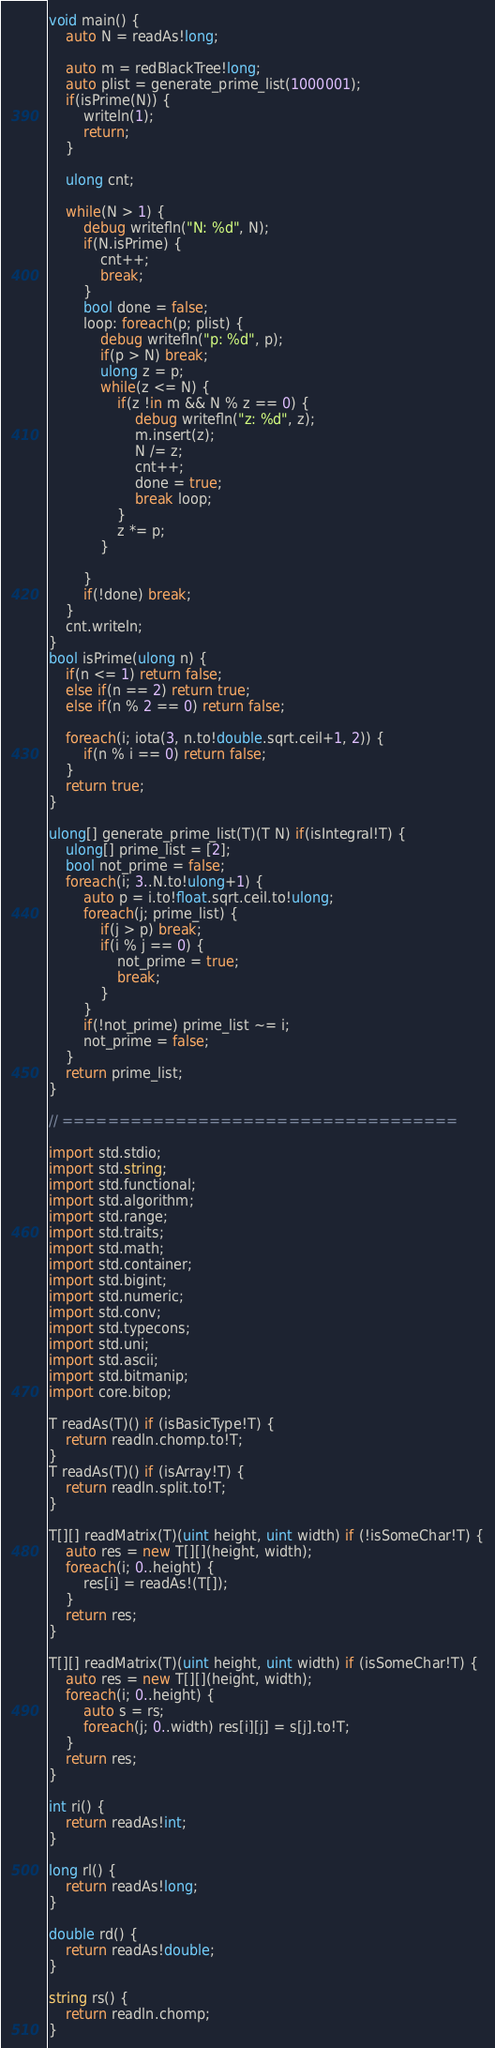<code> <loc_0><loc_0><loc_500><loc_500><_D_>void main() {
	auto N = readAs!long;

	auto m = redBlackTree!long;
	auto plist = generate_prime_list(1000001);
	if(isPrime(N)) {
		writeln(1);
		return;
	}

	ulong cnt;

	while(N > 1) {
		debug writefln("N: %d", N);
		if(N.isPrime) {
			cnt++;
			break;
		}
		bool done = false;
		loop: foreach(p; plist) {
			debug writefln("p: %d", p);
			if(p > N) break;
			ulong z = p;
			while(z <= N) {
				if(z !in m && N % z == 0) {
					debug writefln("z: %d", z);
					m.insert(z);
					N /= z;
					cnt++;
					done = true;
					break loop;
				}
				z *= p;
			}
			
		}
		if(!done) break;
	}
	cnt.writeln;
}
bool isPrime(ulong n) {
	if(n <= 1) return false;
	else if(n == 2) return true;
	else if(n % 2 == 0) return false;

	foreach(i; iota(3, n.to!double.sqrt.ceil+1, 2)) {
		if(n % i == 0) return false;
	}
	return true;
}

ulong[] generate_prime_list(T)(T N) if(isIntegral!T) {
	ulong[] prime_list = [2];
	bool not_prime = false;
	foreach(i; 3..N.to!ulong+1) {
		auto p = i.to!float.sqrt.ceil.to!ulong;
		foreach(j; prime_list) {
			if(j > p) break;
			if(i % j == 0) {
				not_prime = true;
				break;
			}
		}
		if(!not_prime) prime_list ~= i;
		not_prime = false;
	}
	return prime_list;
}

// ===================================

import std.stdio;
import std.string;
import std.functional;
import std.algorithm;
import std.range;
import std.traits;
import std.math;
import std.container;
import std.bigint;
import std.numeric;
import std.conv;
import std.typecons;
import std.uni;
import std.ascii;
import std.bitmanip;
import core.bitop;

T readAs(T)() if (isBasicType!T) {
	return readln.chomp.to!T;
}
T readAs(T)() if (isArray!T) {
	return readln.split.to!T;
}

T[][] readMatrix(T)(uint height, uint width) if (!isSomeChar!T) {
	auto res = new T[][](height, width);
	foreach(i; 0..height) {
		res[i] = readAs!(T[]);
	}
	return res;
}

T[][] readMatrix(T)(uint height, uint width) if (isSomeChar!T) {
	auto res = new T[][](height, width);
	foreach(i; 0..height) {
		auto s = rs;
		foreach(j; 0..width) res[i][j] = s[j].to!T;
	}
	return res;
}

int ri() {
	return readAs!int;
}

long rl() {
	return readAs!long;
}

double rd() {
	return readAs!double;
}

string rs() {
	return readln.chomp;
}</code> 